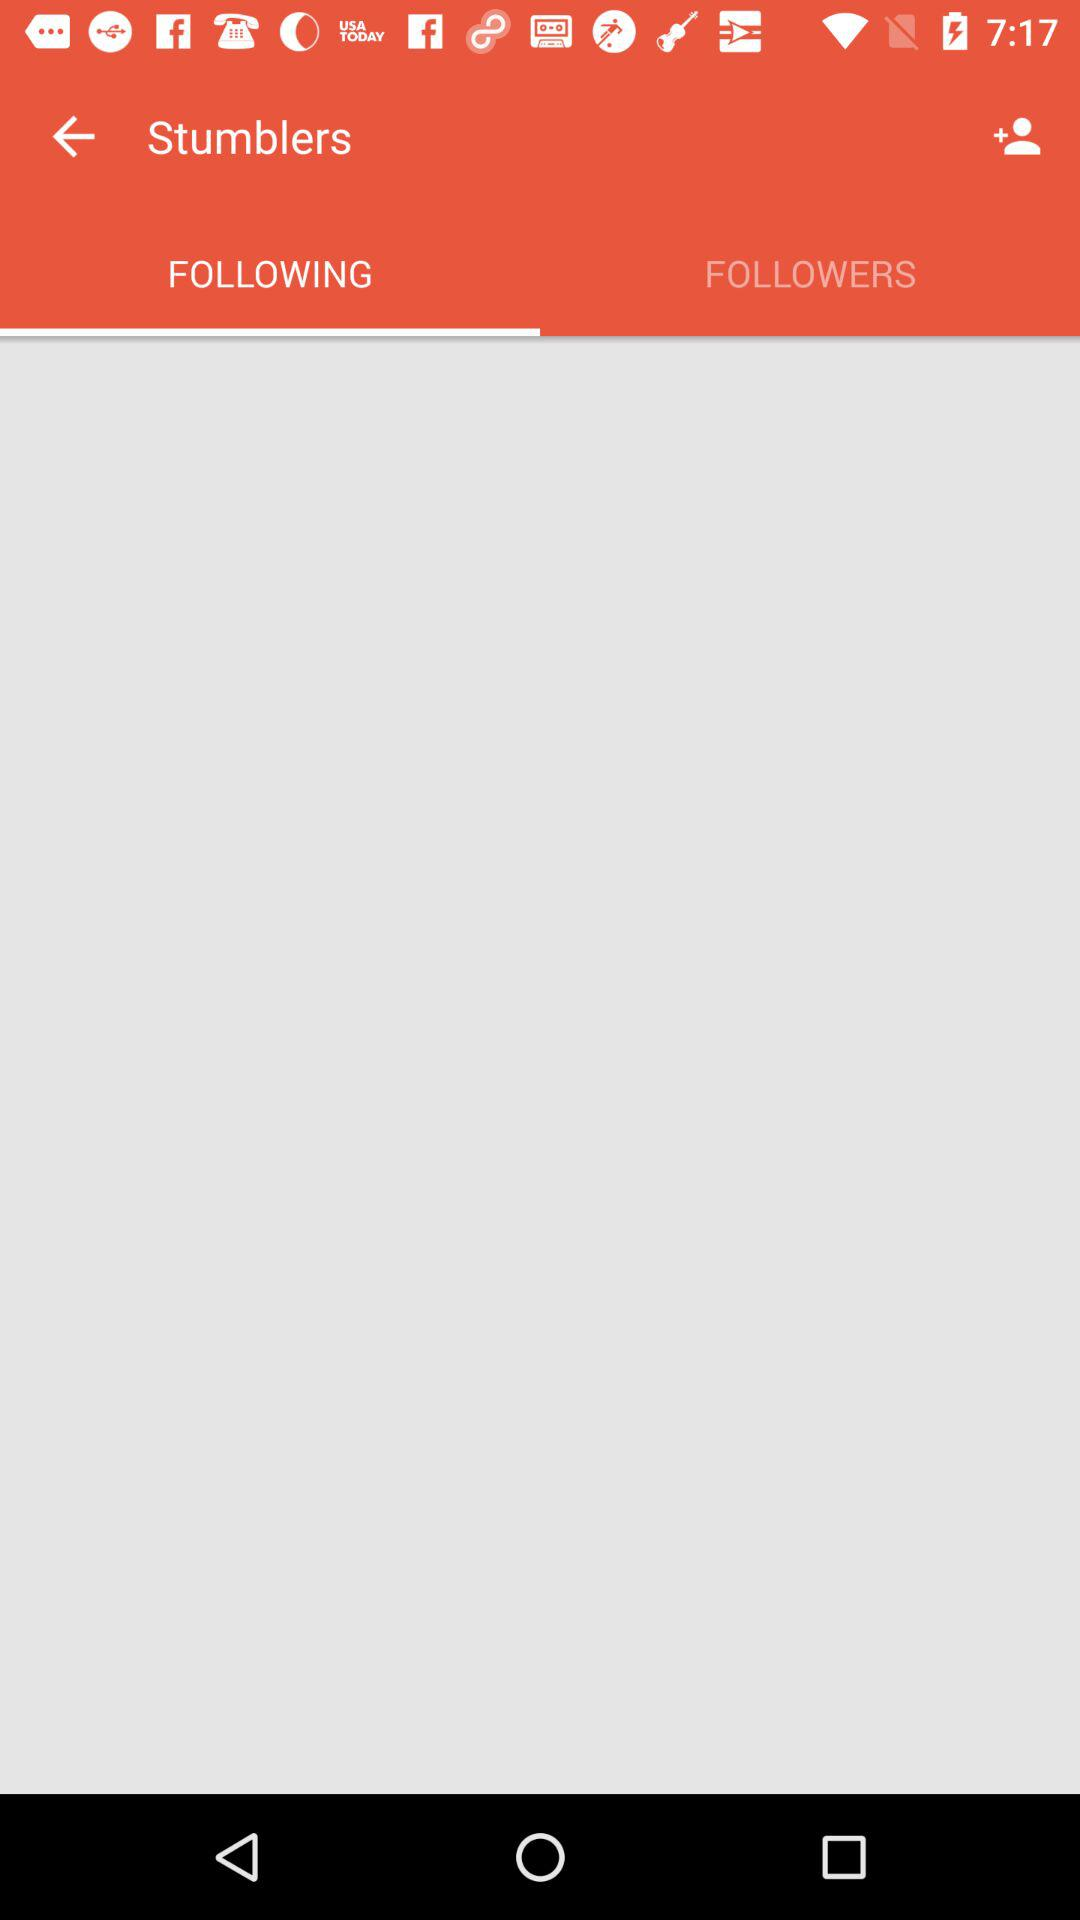Which tab is selected? The selected tab is "FOLLOWING". 